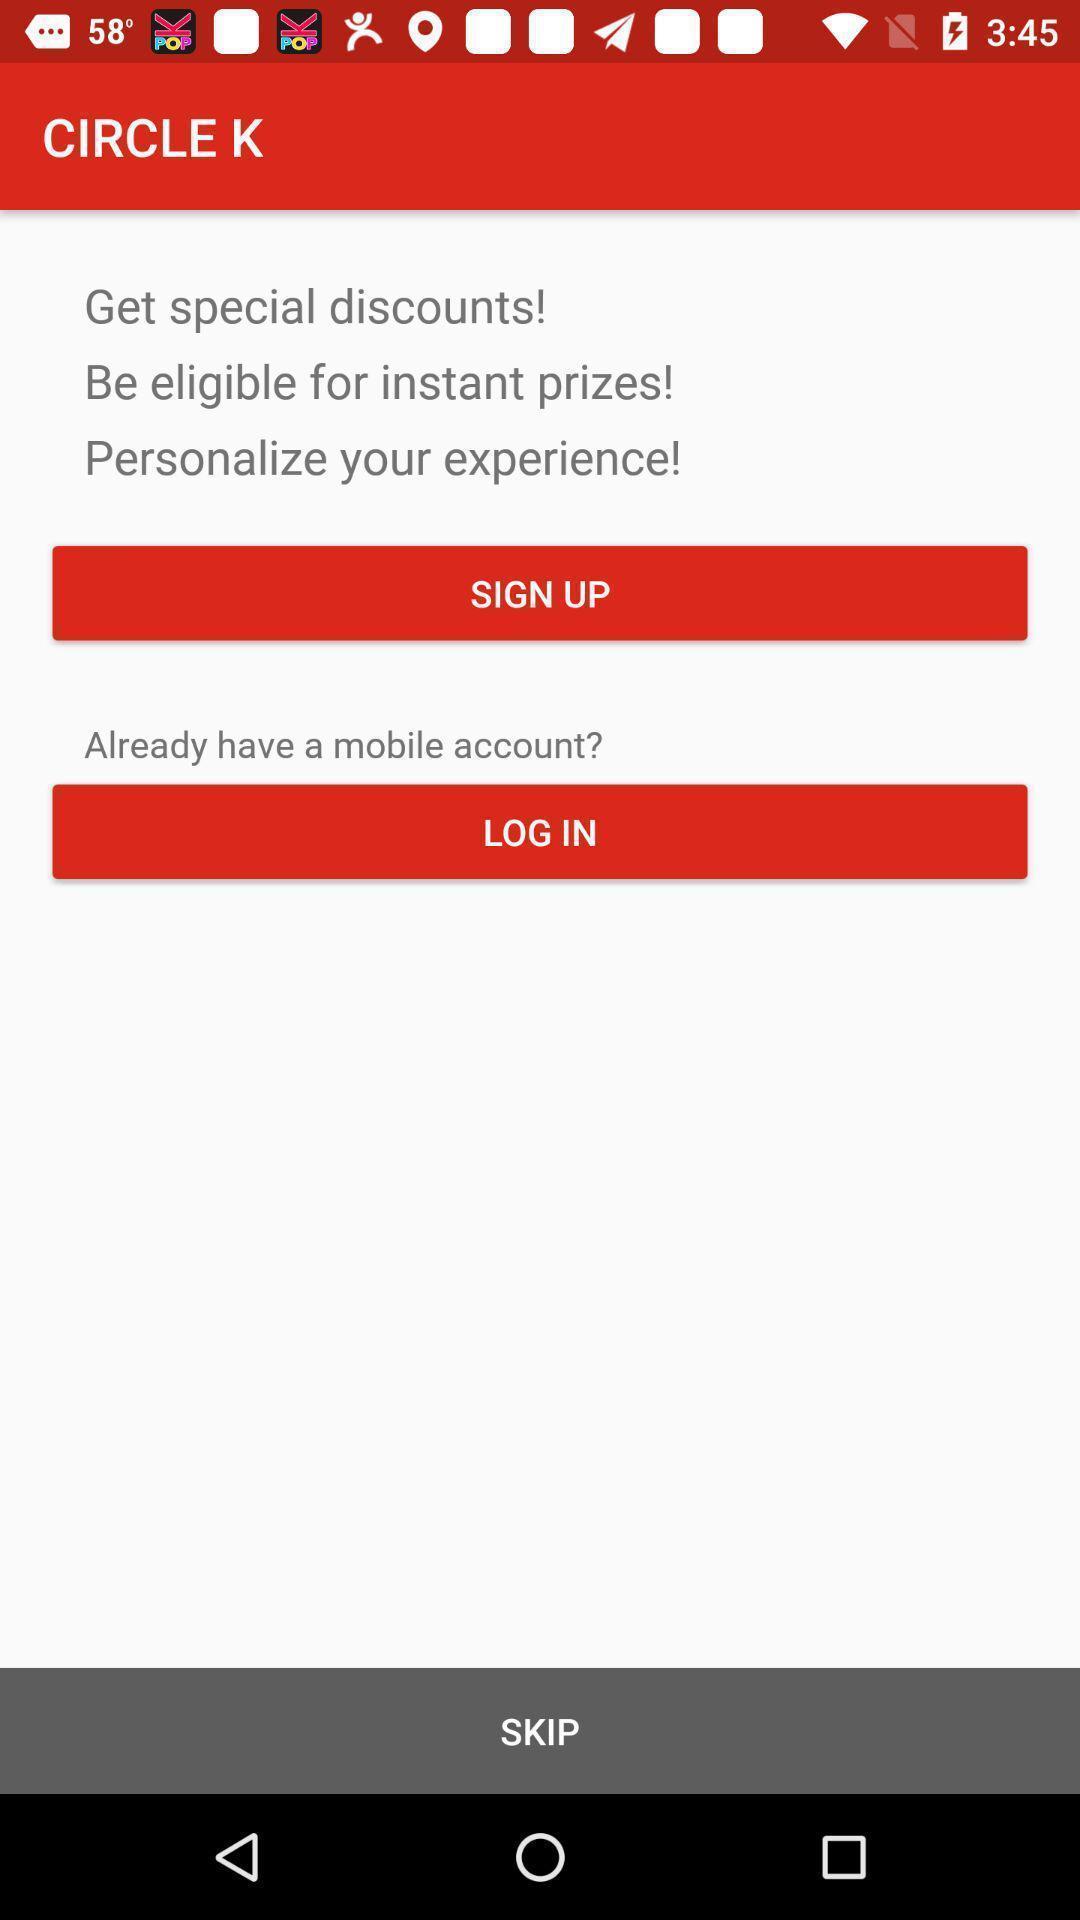Describe the content in this image. Welcome to the sign up page. 